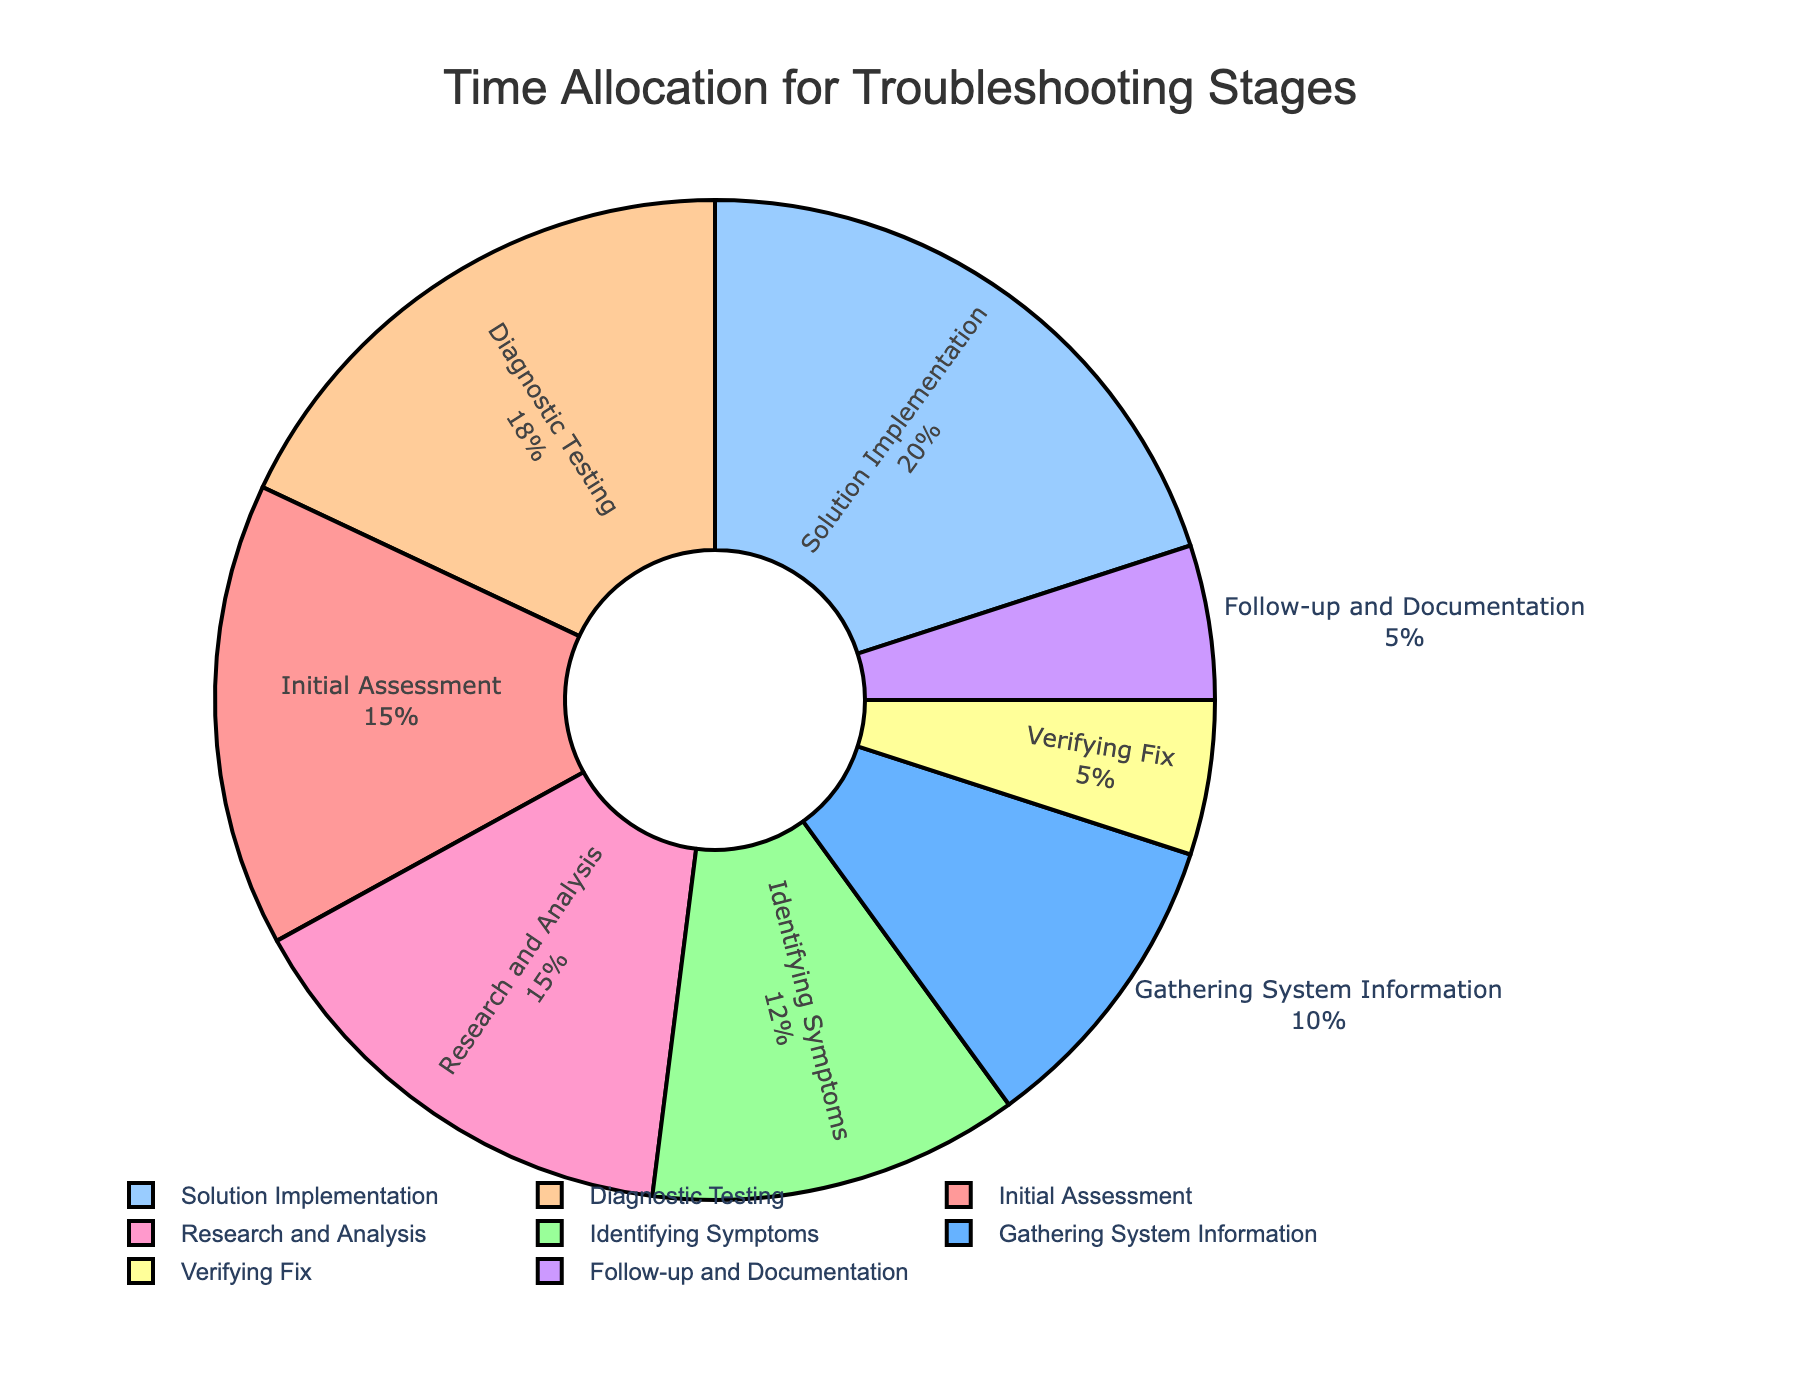which stage has the highest time allocation? Identify the label with the largest percentage from the pie chart. The Solution Implementation stage is the one with the highest time allocation at 20%.
Answer: Solution Implementation which two stages combined take up the same time as Solution Implementation? Add the time allocation for each stage until the sum equals 20%. The Initial Assessment (15%) and Verifying Fix (5%) stages together sum up to 20%.
Answer: Initial Assessment and Verifying Fix what's the total time allocation for stages related to diagnosing the problem (Gathering System Information, Identifying Symptoms, Diagnostic Testing)? Add the time allocations of the three mentioned stages: 10% + 12% + 18% = 40%.
Answer: 40% what's the difference in time allocation between the Research and Analysis stage and the Verifying Fix stage? Subtract the Verifying Fix time allocation from the Research and Analysis time allocation: 15% - 5% = 10%.
Answer: 10% which stage has the lowest time allocation and what is its percentage? Identify the label with the smallest percentage from the pie chart, which is Verifying Fix and Follow-up and Documentation both at 5%.
Answer: Verifying Fix and Follow-up and Documentation, 5% how many stages have a time allocation of 15%? Count the number of labels with a time allocation of 15%. This includes Initial Assessment and Research and Analysis.
Answer: 2 which stage is represented by the blue segment? Identify the color legend if available or visually inspecting the chart. The Diagnostic Testing stage is represented by blue.
Answer: Diagnostic Testing which stage takes twice as much time as the Verifying Fix? Multiply the Verifying Fix time allocation by 2 and find the stage with the matching allocation. 5% * 2 = 10%, which corresponds to the Gathering System Information stage.
Answer: Gathering System Information which stages have equal time allocations? Compare all percentages to find matching values. Verifying Fix and Follow-up and Documentation both have 5%.
Answer: Verifying Fix and Follow-up and Documentation 